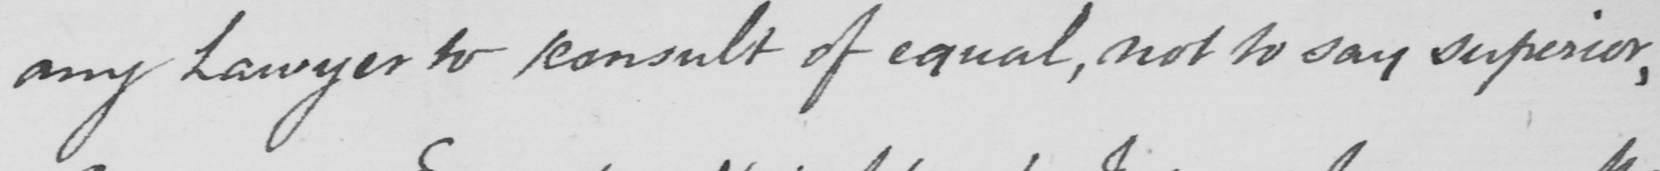Can you tell me what this handwritten text says? any Lawyer to consult of equal , not to say superior , 